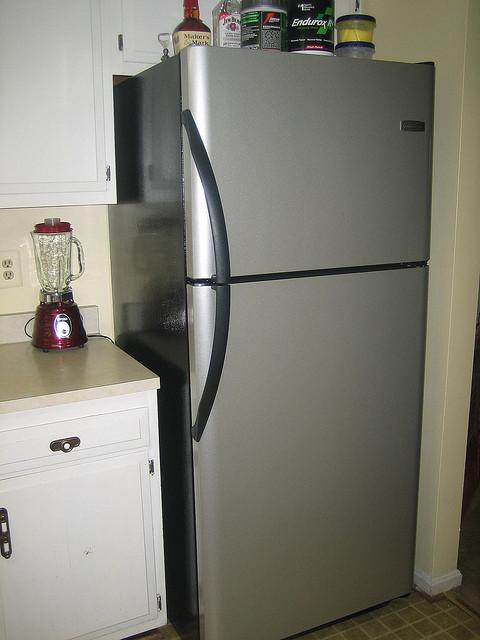Does the fridge have an ice maker on the outside of it?
Write a very short answer. No. Does the doors open to left or right?
Short answer required. Right. Is that liquor on top of the fridge?
Keep it brief. Yes. 